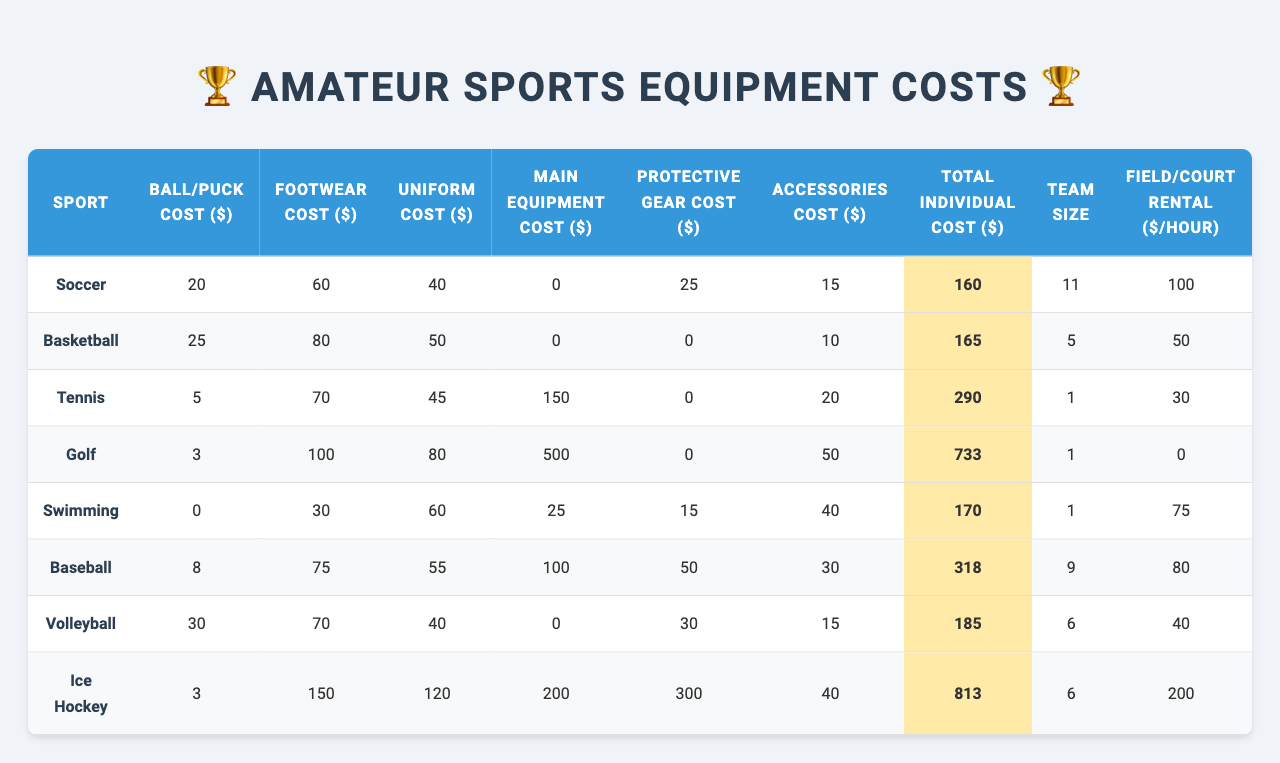What's the total individual cost for swimming? The table shows that the total individual cost for swimming is $170.
Answer: 170 Which sport has the highest total individual cost? By comparing all the total individual costs, Ice Hockey has the highest cost at $813.
Answer: Ice Hockey Is the footwear cost for volleyball higher than that for soccer? Volleyball footwear cost is $70, while soccer's is $60; therefore, yes, volleyball's footwear cost is higher.
Answer: Yes What is the average ball/puck cost across all sports? The total ball/puck cost is $20 + $25 + $5 + $3 + $0 + $8 + $30 + $3 = $94, and there are 8 sports, so the average is $94/8 = $11.75.
Answer: 11.75 Which sport has the lowest combined cost of ball/puck and protective gear? Adding the ball/puck cost and protective gear cost for each sport, Swimming has $0 + $15 = $15, which is the lowest.
Answer: Swimming Is the field rental cost for soccer more than the combined protective gear cost for tennis and baseball? Tennis has $0 and baseball has $50 for protective gear, totaling $50. Soccer's field rental is $100, so yes, it is more.
Answer: Yes What is the difference between the total individual costs for basketball and soccer? Basketball's cost is $165, and soccer's is $160. The difference is $165 - $160 = $5.
Answer: 5 If the main equipment cost for golf is removed, what would be the new total individual cost for golf? Removing golf's main equipment cost of $500 from the total individual cost of $733 gives a new total of $733 - $500 = $233.
Answer: 233 What is the total footwear cost for all sports? Summing up footwear costs: $60 + $80 + $70 + $100 + $30 + $75 + $70 + $150 = $635.
Answer: 635 Is the team size for baseball greater than that for tennis? Baseball has a team size of 9, while tennis has a team size of 1; thus, yes, baseball's team size is greater.
Answer: Yes 